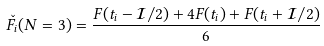Convert formula to latex. <formula><loc_0><loc_0><loc_500><loc_500>\check { F } _ { i } ( N = 3 ) = \frac { F ( t _ { i } - \mathcal { I } / 2 ) + 4 F ( t _ { i } ) + F ( t _ { i } + \mathcal { I } / 2 ) } { 6 }</formula> 